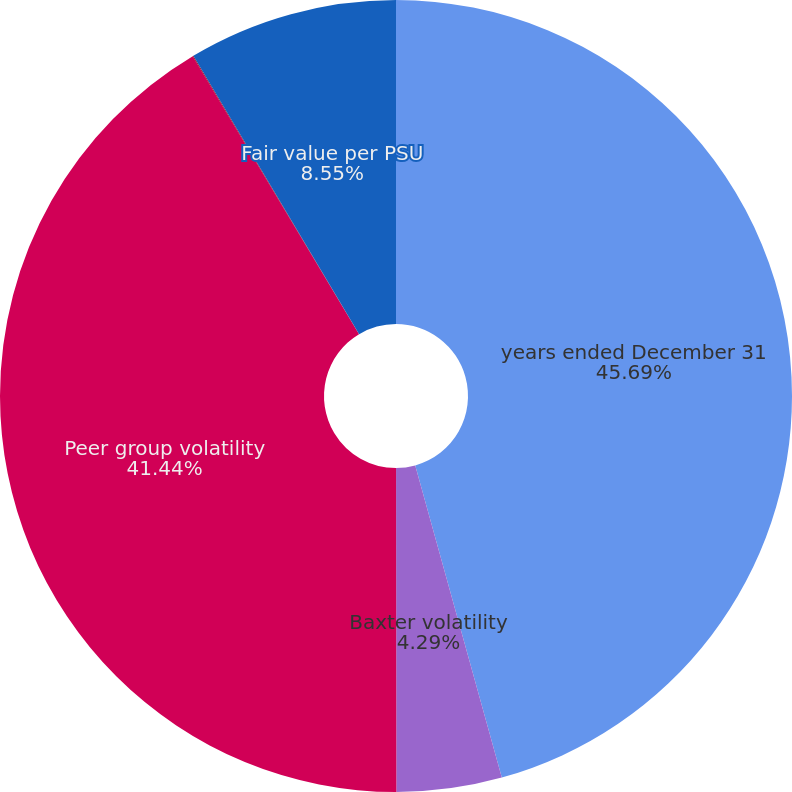<chart> <loc_0><loc_0><loc_500><loc_500><pie_chart><fcel>years ended December 31<fcel>Baxter volatility<fcel>Peer group volatility<fcel>Risk-free interest rate<fcel>Fair value per PSU<nl><fcel>45.7%<fcel>4.29%<fcel>41.44%<fcel>0.03%<fcel>8.55%<nl></chart> 